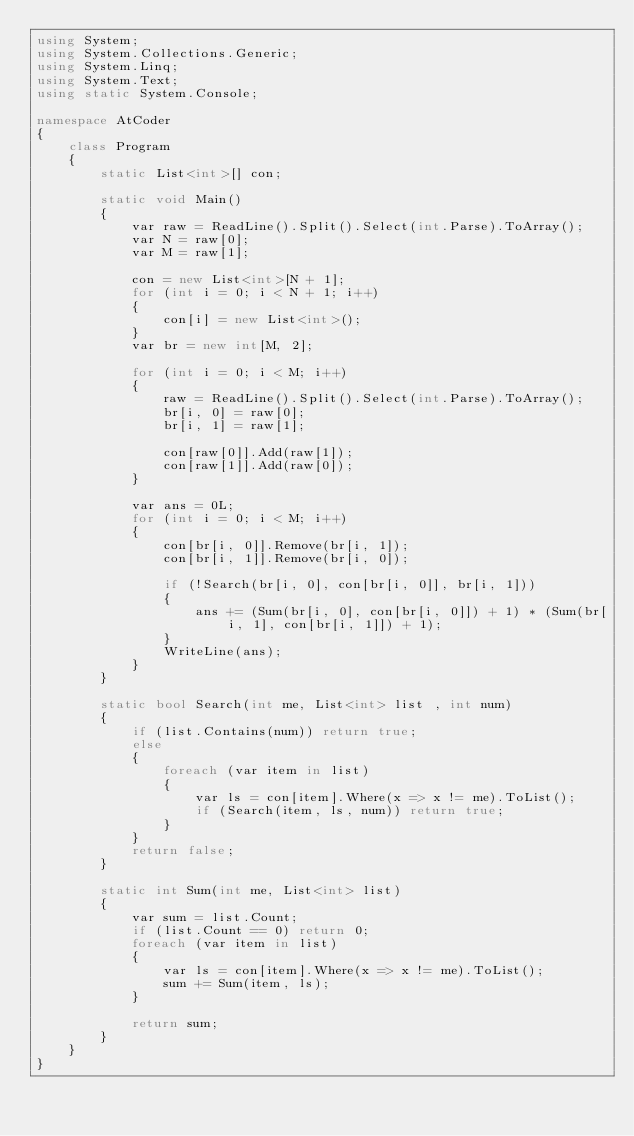Convert code to text. <code><loc_0><loc_0><loc_500><loc_500><_C#_>using System;
using System.Collections.Generic;
using System.Linq;
using System.Text;
using static System.Console;

namespace AtCoder
{
    class Program
    {
        static List<int>[] con;

        static void Main()
        {
            var raw = ReadLine().Split().Select(int.Parse).ToArray();
            var N = raw[0];
            var M = raw[1];

            con = new List<int>[N + 1];
            for (int i = 0; i < N + 1; i++)
            {
                con[i] = new List<int>();
            }
            var br = new int[M, 2];

            for (int i = 0; i < M; i++)
            {
                raw = ReadLine().Split().Select(int.Parse).ToArray();
                br[i, 0] = raw[0];
                br[i, 1] = raw[1];

                con[raw[0]].Add(raw[1]);
                con[raw[1]].Add(raw[0]);
            }

            var ans = 0L;
            for (int i = 0; i < M; i++)
            {
                con[br[i, 0]].Remove(br[i, 1]);
                con[br[i, 1]].Remove(br[i, 0]);

                if (!Search(br[i, 0], con[br[i, 0]], br[i, 1]))
                {
                    ans += (Sum(br[i, 0], con[br[i, 0]]) + 1) * (Sum(br[i, 1], con[br[i, 1]]) + 1);
                }
                WriteLine(ans);
            }
        }

        static bool Search(int me, List<int> list , int num)
        {
            if (list.Contains(num)) return true;
            else
            {
                foreach (var item in list)
                {
                    var ls = con[item].Where(x => x != me).ToList();
                    if (Search(item, ls, num)) return true;
                }
            }
            return false;
        }

        static int Sum(int me, List<int> list)
        {
            var sum = list.Count;
            if (list.Count == 0) return 0;
            foreach (var item in list)
            {
                var ls = con[item].Where(x => x != me).ToList();
                sum += Sum(item, ls);
            }

            return sum;
        }
    }
}
</code> 